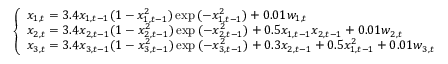Convert formula to latex. <formula><loc_0><loc_0><loc_500><loc_500>\left \{ \begin{array} { l l } { x _ { 1 , t } = 3 . 4 x _ { 1 , t - 1 } ( 1 - x _ { 1 , t - 1 } ^ { 2 } ) \exp { ( - x _ { 1 , t - 1 } ^ { 2 } ) } + 0 . 0 1 w _ { 1 , t } } \\ { x _ { 2 , t } = 3 . 4 x _ { 2 , t - 1 } ( 1 - x _ { 2 , t - 1 } ^ { 2 } ) \exp { ( - x _ { 2 , t - 1 } ^ { 2 } ) } + 0 . 5 x _ { 1 , t - 1 } x _ { 2 , t - 1 } + 0 . 0 1 w _ { 2 , t } } \\ { x _ { 3 , t } = 3 . 4 x _ { 3 , t - 1 } ( 1 - x _ { 3 , t - 1 } ^ { 2 } ) \exp { ( - x _ { 3 , t - 1 } ^ { 2 } ) } + 0 . 3 x _ { 2 , t - 1 } + 0 . 5 x _ { 1 , t - 1 } ^ { 2 } + 0 . 0 1 w _ { 3 , t } } \end{array}</formula> 